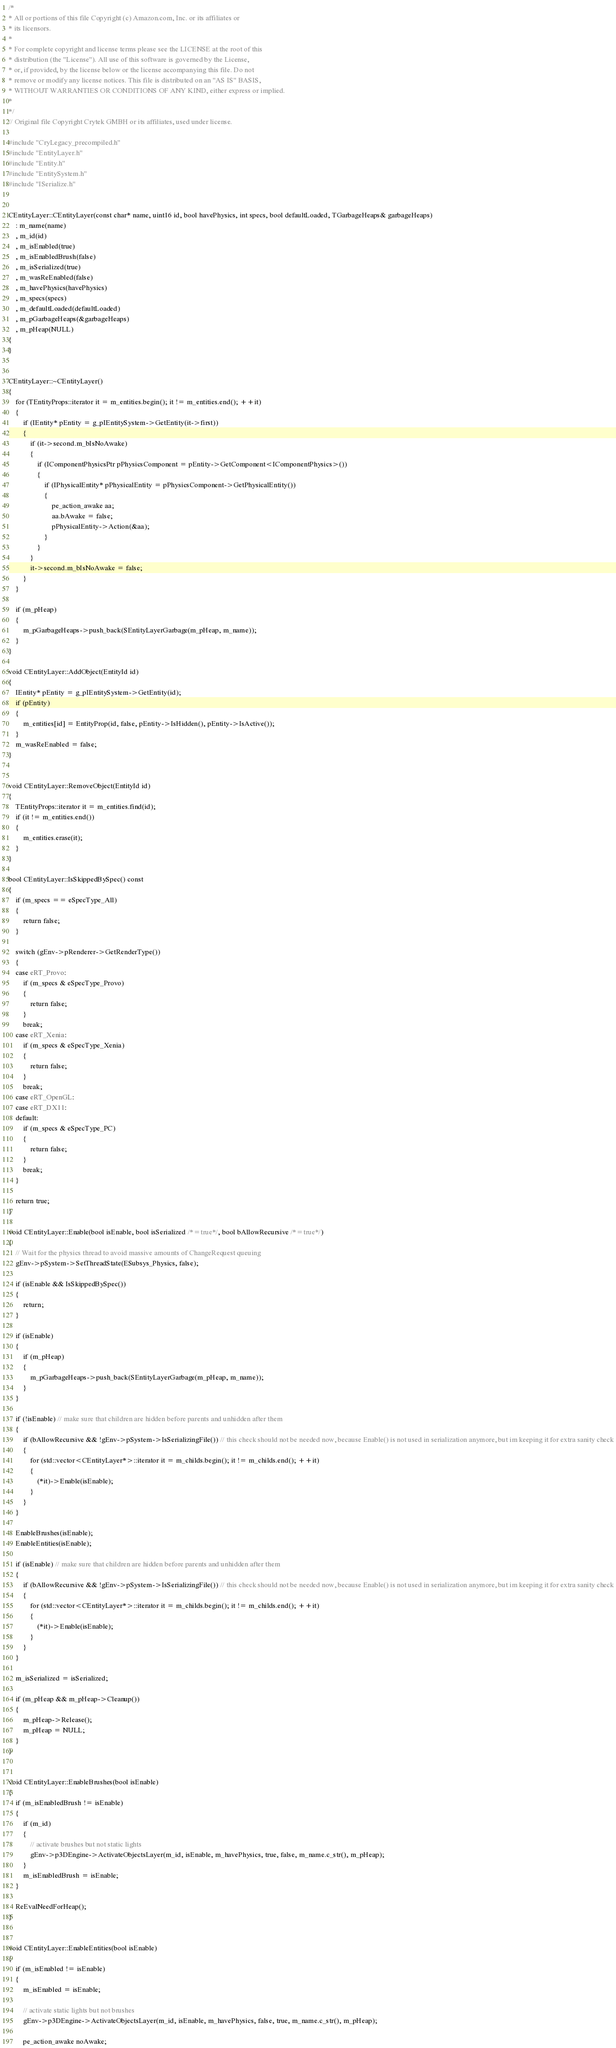Convert code to text. <code><loc_0><loc_0><loc_500><loc_500><_C++_>/*
* All or portions of this file Copyright (c) Amazon.com, Inc. or its affiliates or
* its licensors.
*
* For complete copyright and license terms please see the LICENSE at the root of this
* distribution (the "License"). All use of this software is governed by the License,
* or, if provided, by the license below or the license accompanying this file. Do not
* remove or modify any license notices. This file is distributed on an "AS IS" BASIS,
* WITHOUT WARRANTIES OR CONDITIONS OF ANY KIND, either express or implied.
*
*/
// Original file Copyright Crytek GMBH or its affiliates, used under license.

#include "CryLegacy_precompiled.h"
#include "EntityLayer.h"
#include "Entity.h"
#include "EntitySystem.h"
#include "ISerialize.h"


CEntityLayer::CEntityLayer(const char* name, uint16 id, bool havePhysics, int specs, bool defaultLoaded, TGarbageHeaps& garbageHeaps)
    : m_name(name)
    , m_id(id)
    , m_isEnabled(true)
    , m_isEnabledBrush(false)
    , m_isSerialized(true)
    , m_wasReEnabled(false)
    , m_havePhysics(havePhysics)
    , m_specs(specs)
    , m_defaultLoaded(defaultLoaded)
    , m_pGarbageHeaps(&garbageHeaps)
    , m_pHeap(NULL)
{
}


CEntityLayer::~CEntityLayer()
{
    for (TEntityProps::iterator it = m_entities.begin(); it != m_entities.end(); ++it)
    {
        if (IEntity* pEntity = g_pIEntitySystem->GetEntity(it->first))
        {
            if (it->second.m_bIsNoAwake)
            {
                if (IComponentPhysicsPtr pPhysicsComponent = pEntity->GetComponent<IComponentPhysics>())
                {
                    if (IPhysicalEntity* pPhysicalEntity = pPhysicsComponent->GetPhysicalEntity())
                    {
                        pe_action_awake aa;
                        aa.bAwake = false;
                        pPhysicalEntity->Action(&aa);
                    }
                }
            }
            it->second.m_bIsNoAwake = false;
        }
    }

    if (m_pHeap)
    {
        m_pGarbageHeaps->push_back(SEntityLayerGarbage(m_pHeap, m_name));
    }
}

void CEntityLayer::AddObject(EntityId id)
{
    IEntity* pEntity = g_pIEntitySystem->GetEntity(id);
    if (pEntity)
    {
        m_entities[id] = EntityProp(id, false, pEntity->IsHidden(), pEntity->IsActive());
    }
    m_wasReEnabled = false;
}


void CEntityLayer::RemoveObject(EntityId id)
{
    TEntityProps::iterator it = m_entities.find(id);
    if (it != m_entities.end())
    {
        m_entities.erase(it);
    }
}

bool CEntityLayer::IsSkippedBySpec() const
{
    if (m_specs == eSpecType_All)
    {
        return false;
    }

    switch (gEnv->pRenderer->GetRenderType())
    {
    case eRT_Provo:
        if (m_specs & eSpecType_Provo)
        {
            return false;
        }
        break;
    case eRT_Xenia:
        if (m_specs & eSpecType_Xenia)
        {
            return false;
        }
        break;
    case eRT_OpenGL:
    case eRT_DX11:
    default:
        if (m_specs & eSpecType_PC)
        {
            return false;
        }
        break;
    }

    return true;
}

void CEntityLayer::Enable(bool isEnable, bool isSerialized /*=true*/, bool bAllowRecursive /*=true*/)
{
    // Wait for the physics thread to avoid massive amounts of ChangeRequest queuing
    gEnv->pSystem->SetThreadState(ESubsys_Physics, false);

    if (isEnable && IsSkippedBySpec())
    {
        return;
    }

    if (isEnable)
    {
        if (m_pHeap)
        {
            m_pGarbageHeaps->push_back(SEntityLayerGarbage(m_pHeap, m_name));
        }
    }

    if (!isEnable) // make sure that children are hidden before parents and unhidden after them
    {
        if (bAllowRecursive && !gEnv->pSystem->IsSerializingFile()) // this check should not be needed now, because Enable() is not used in serialization anymore, but im keeping it for extra sanity check
        {
            for (std::vector<CEntityLayer*>::iterator it = m_childs.begin(); it != m_childs.end(); ++it)
            {
                (*it)->Enable(isEnable);
            }
        }
    }

    EnableBrushes(isEnable);
    EnableEntities(isEnable);

    if (isEnable) // make sure that children are hidden before parents and unhidden after them
    {
        if (bAllowRecursive && !gEnv->pSystem->IsSerializingFile()) // this check should not be needed now, because Enable() is not used in serialization anymore, but im keeping it for extra sanity check
        {
            for (std::vector<CEntityLayer*>::iterator it = m_childs.begin(); it != m_childs.end(); ++it)
            {
                (*it)->Enable(isEnable);
            }
        }
    }

    m_isSerialized = isSerialized;

    if (m_pHeap && m_pHeap->Cleanup())
    {
        m_pHeap->Release();
        m_pHeap = NULL;
    }
}


void CEntityLayer::EnableBrushes(bool isEnable)
{
    if (m_isEnabledBrush != isEnable)
    {
        if (m_id)
        {
            // activate brushes but not static lights
            gEnv->p3DEngine->ActivateObjectsLayer(m_id, isEnable, m_havePhysics, true, false, m_name.c_str(), m_pHeap);
        }
        m_isEnabledBrush = isEnable;
    }

    ReEvalNeedForHeap();
}


void CEntityLayer::EnableEntities(bool isEnable)
{
    if (m_isEnabled != isEnable)
    {
        m_isEnabled = isEnable;

        // activate static lights but not brushes
        gEnv->p3DEngine->ActivateObjectsLayer(m_id, isEnable, m_havePhysics, false, true, m_name.c_str(), m_pHeap);

        pe_action_awake noAwake;</code> 